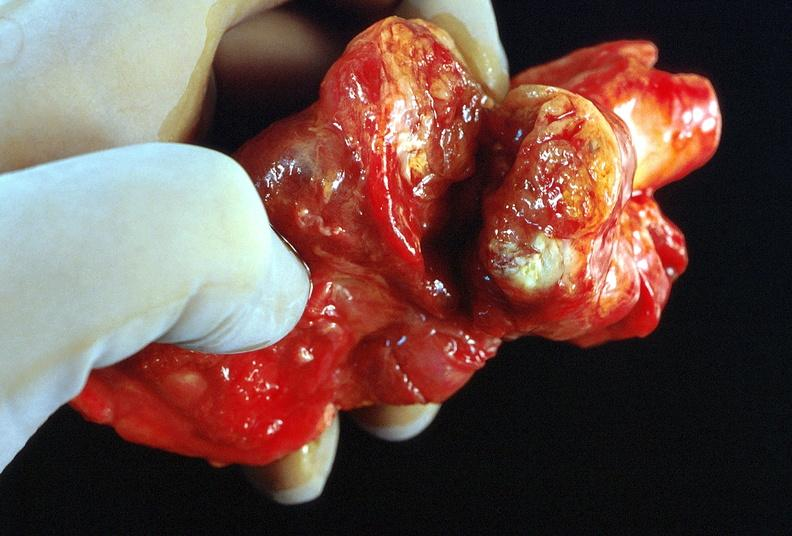does atrophy show thyroid, goiter?
Answer the question using a single word or phrase. No 